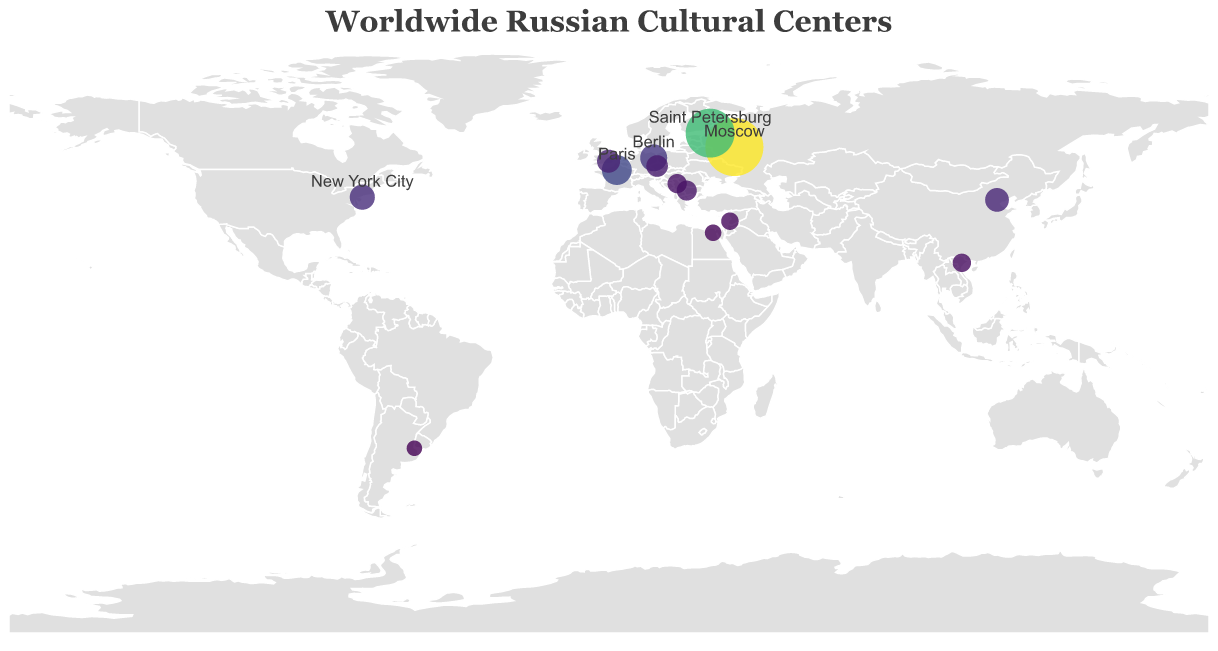How many cultural centers are located in Russia? The figure shows two locations with labels in Russia: Moscow and Saint Petersburg.
Answer: 2 Which city has the highest annual visitor number? From the size and color of the circles, the largest circle is associated with Moscow. The tooltip confirms 500,000 annual visitors.
Answer: Moscow What is the combined total of annual visitors for the cultural centers in Russia? Moscow has 500,000 visitors and Saint Petersburg has 350,000 visitors. Adding these gives 500,000 + 350,000 = 850,000.
Answer: 850,000 How do the visitor numbers in Paris compare to those in Berlin? Paris has 120,000 visitors, while Berlin has 95,000. Paris has more visitors than Berlin.
Answer: Paris has more What two cities are displayed with the smallest circles, representing the lowest annual visitor numbers? The smallest circles would be for Buenos Aires (20,000) and Cairo (25,000), as confirmed by the tooltip details.
Answer: Buenos Aires and Cairo Which cultural center has more annual visitors: New York City or Beijing? From the figure, New York City's circle is larger than Beijing's. New York City has 80,000 visitors, while Beijing has 70,000 visitors.
Answer: New York City What is the average annual visitor number for all centers listed? Sum of all visitor numbers: 500,000 (Moscow) + 350,000 (Saint Petersburg) + 120,000 (Paris) + 95,000 (Berlin) + 80,000 (New York City) + 70,000 (Beijing) + 65,000 (London) + 55,000 (Prague) + 45,000 (Sofia) + 40,000 (Belgrade) + 35,000 (Hanoi) + 30,000 (Damascus) + 25,000 (Cairo) + 20,000 (Buenos Aires) = 1,530,000. There are 14 centers, so average = 1,530,000/14 ≈ 109,286
Answer: 109,286 What is the distribution type of visitor numbers by color in the figure? The color scheme ranges from yellow to dark blue, correlating to the number of visitors. High numbers use darker shades (blue), and low numbers use lighter shades (yellow).
Answer: Darker shades represent higher numbers, lighter shades represent lower numbers What cities in Asia have Russian cultural centers? The cities in Asia shown in the figure are Beijing (China), Hanoi (Vietnam), and Damascus (Syria).
Answer: Beijing, Hanoi, and Damascus How many cultural centers have fewer than 50,000 annual visitors? From the tooltip details: Belgrade (40,000), Hanoi (35,000), Damascus (30,000), Cairo (25,000), and Buenos Aires (20,000) are below 50,000. That totals 5 centers.
Answer: 5 